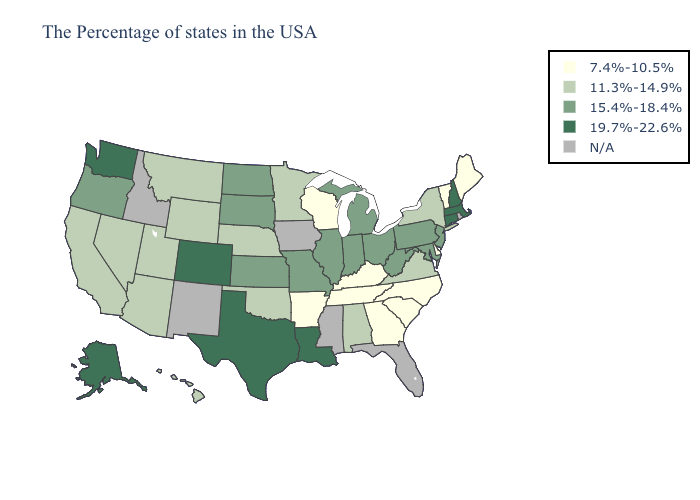How many symbols are there in the legend?
Write a very short answer. 5. Name the states that have a value in the range 7.4%-10.5%?
Write a very short answer. Maine, Vermont, Delaware, North Carolina, South Carolina, Georgia, Kentucky, Tennessee, Wisconsin, Arkansas. Does Alabama have the highest value in the South?
Answer briefly. No. Name the states that have a value in the range 19.7%-22.6%?
Be succinct. Massachusetts, New Hampshire, Connecticut, Louisiana, Texas, Colorado, Washington, Alaska. Among the states that border Iowa , does Wisconsin have the lowest value?
Concise answer only. Yes. What is the value of Louisiana?
Concise answer only. 19.7%-22.6%. What is the highest value in the USA?
Keep it brief. 19.7%-22.6%. What is the highest value in states that border Arkansas?
Give a very brief answer. 19.7%-22.6%. Name the states that have a value in the range 7.4%-10.5%?
Keep it brief. Maine, Vermont, Delaware, North Carolina, South Carolina, Georgia, Kentucky, Tennessee, Wisconsin, Arkansas. Does Pennsylvania have the highest value in the Northeast?
Quick response, please. No. What is the lowest value in states that border Idaho?
Concise answer only. 11.3%-14.9%. Name the states that have a value in the range 19.7%-22.6%?
Answer briefly. Massachusetts, New Hampshire, Connecticut, Louisiana, Texas, Colorado, Washington, Alaska. What is the value of New York?
Give a very brief answer. 11.3%-14.9%. Name the states that have a value in the range 15.4%-18.4%?
Concise answer only. New Jersey, Maryland, Pennsylvania, West Virginia, Ohio, Michigan, Indiana, Illinois, Missouri, Kansas, South Dakota, North Dakota, Oregon. 